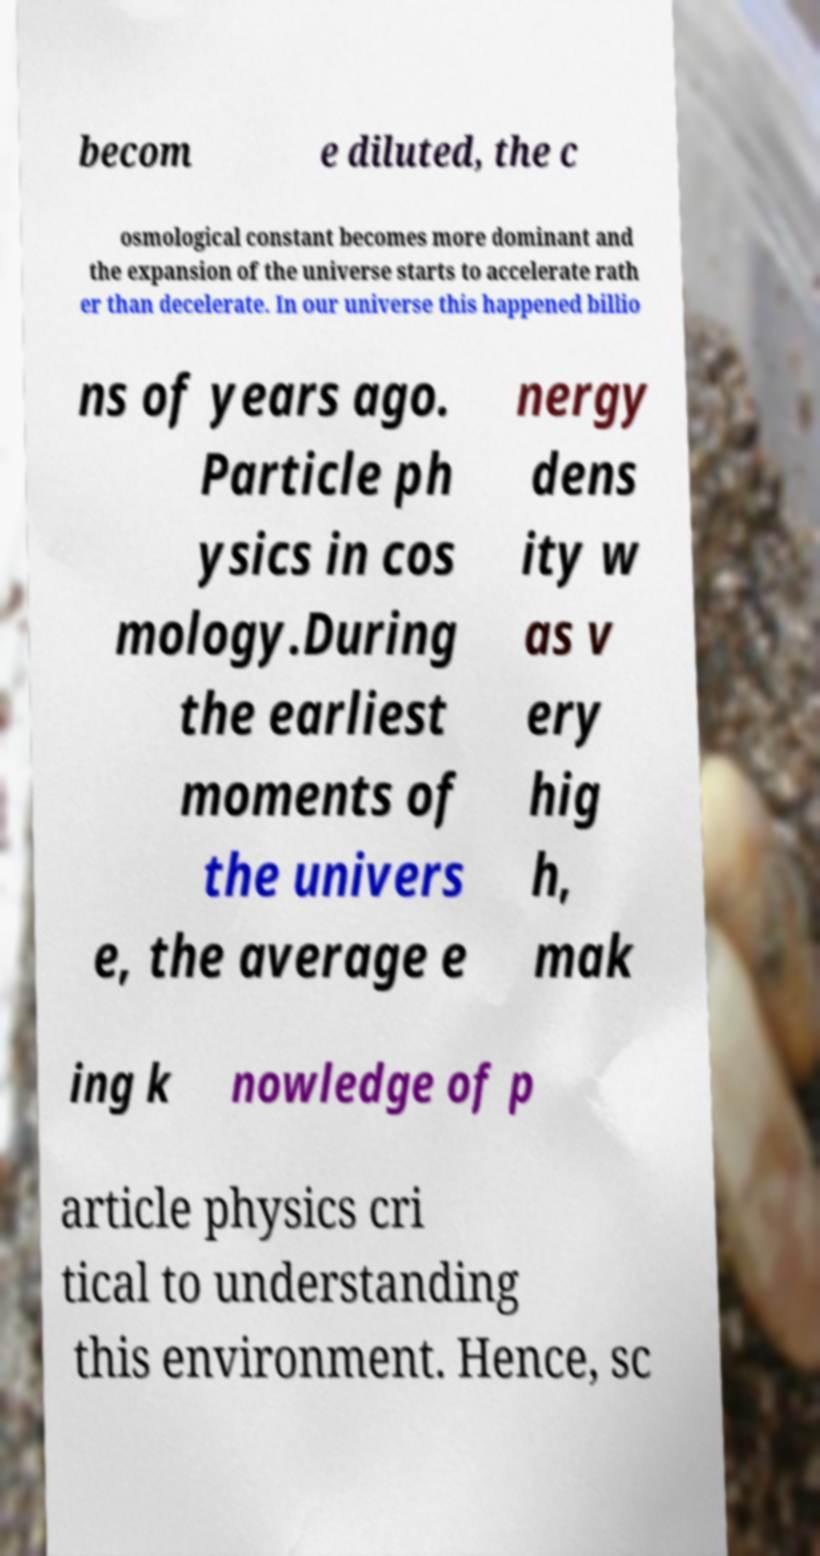Can you read and provide the text displayed in the image?This photo seems to have some interesting text. Can you extract and type it out for me? becom e diluted, the c osmological constant becomes more dominant and the expansion of the universe starts to accelerate rath er than decelerate. In our universe this happened billio ns of years ago. Particle ph ysics in cos mology.During the earliest moments of the univers e, the average e nergy dens ity w as v ery hig h, mak ing k nowledge of p article physics cri tical to understanding this environment. Hence, sc 